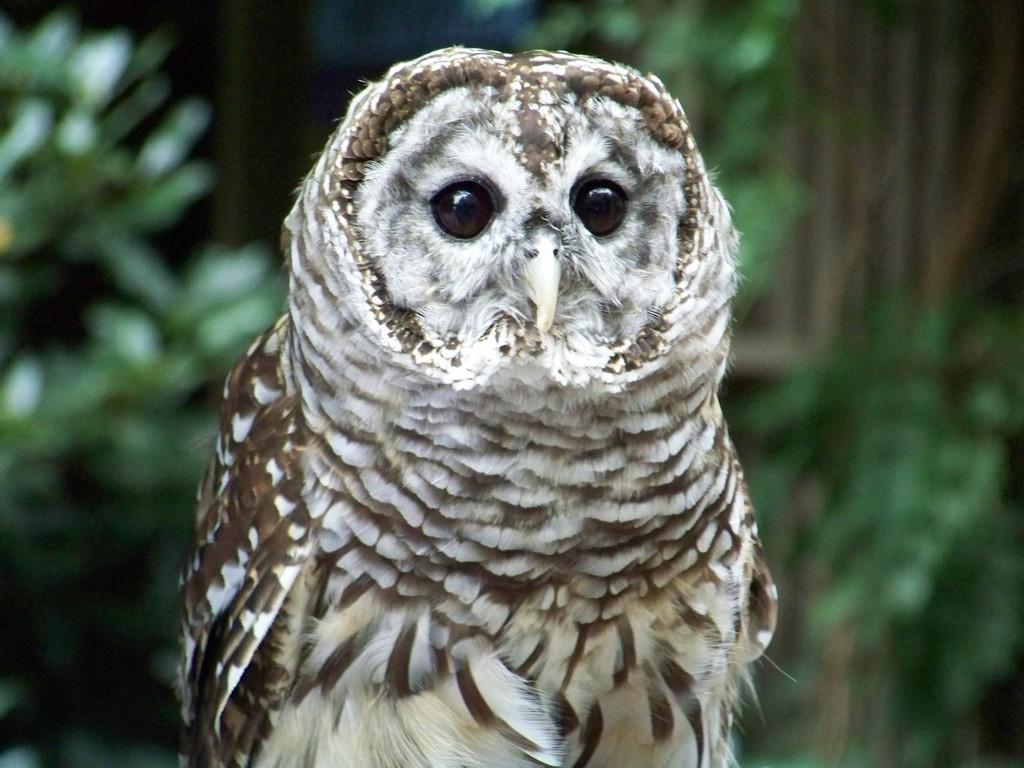In one or two sentences, can you explain what this image depicts? In this image we can see an owl. There are many trees in the image as the background. 